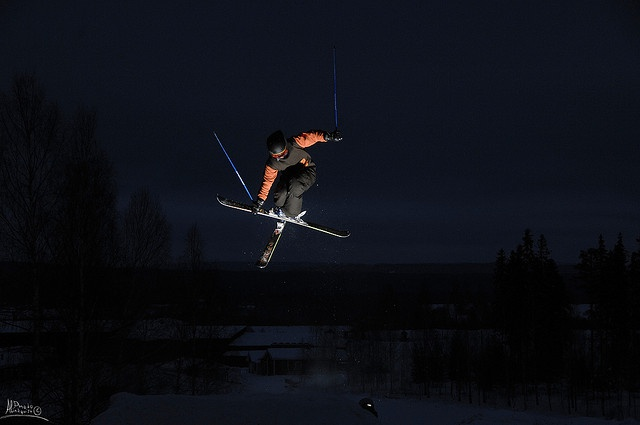Describe the objects in this image and their specific colors. I can see people in black, gray, salmon, and maroon tones and skis in black, gray, lightgray, and darkgray tones in this image. 